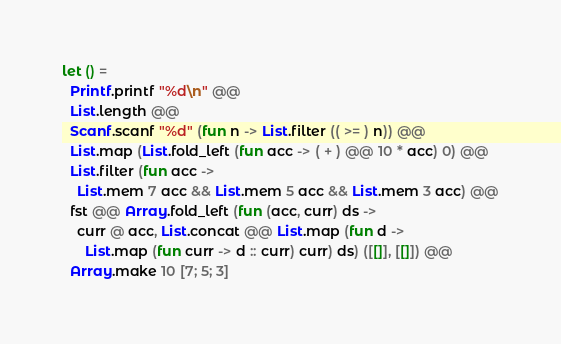Convert code to text. <code><loc_0><loc_0><loc_500><loc_500><_OCaml_>let () = 
  Printf.printf "%d\n" @@
  List.length @@
  Scanf.scanf "%d" (fun n -> List.filter (( >= ) n)) @@
  List.map (List.fold_left (fun acc -> ( + ) @@ 10 * acc) 0) @@
  List.filter (fun acc ->
    List.mem 7 acc && List.mem 5 acc && List.mem 3 acc) @@
  fst @@ Array.fold_left (fun (acc, curr) ds ->
    curr @ acc, List.concat @@ List.map (fun d ->
      List.map (fun curr -> d :: curr) curr) ds) ([[]], [[]]) @@
  Array.make 10 [7; 5; 3]</code> 